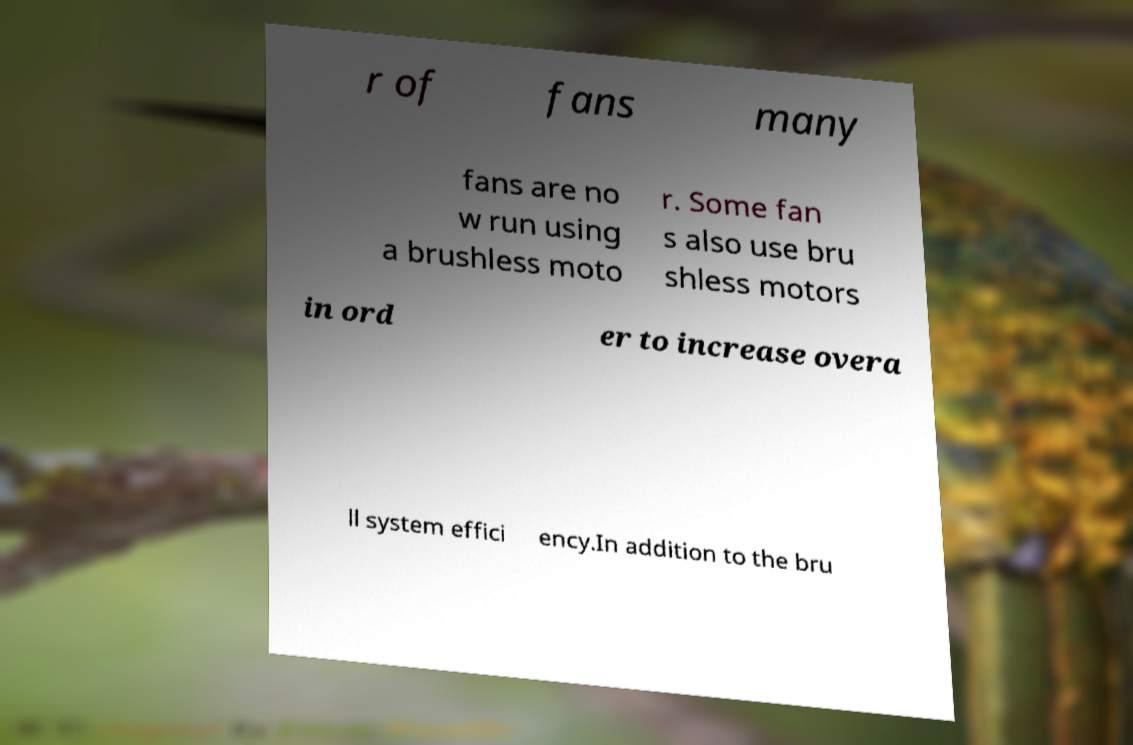Can you read and provide the text displayed in the image?This photo seems to have some interesting text. Can you extract and type it out for me? r of fans many fans are no w run using a brushless moto r. Some fan s also use bru shless motors in ord er to increase overa ll system effici ency.In addition to the bru 